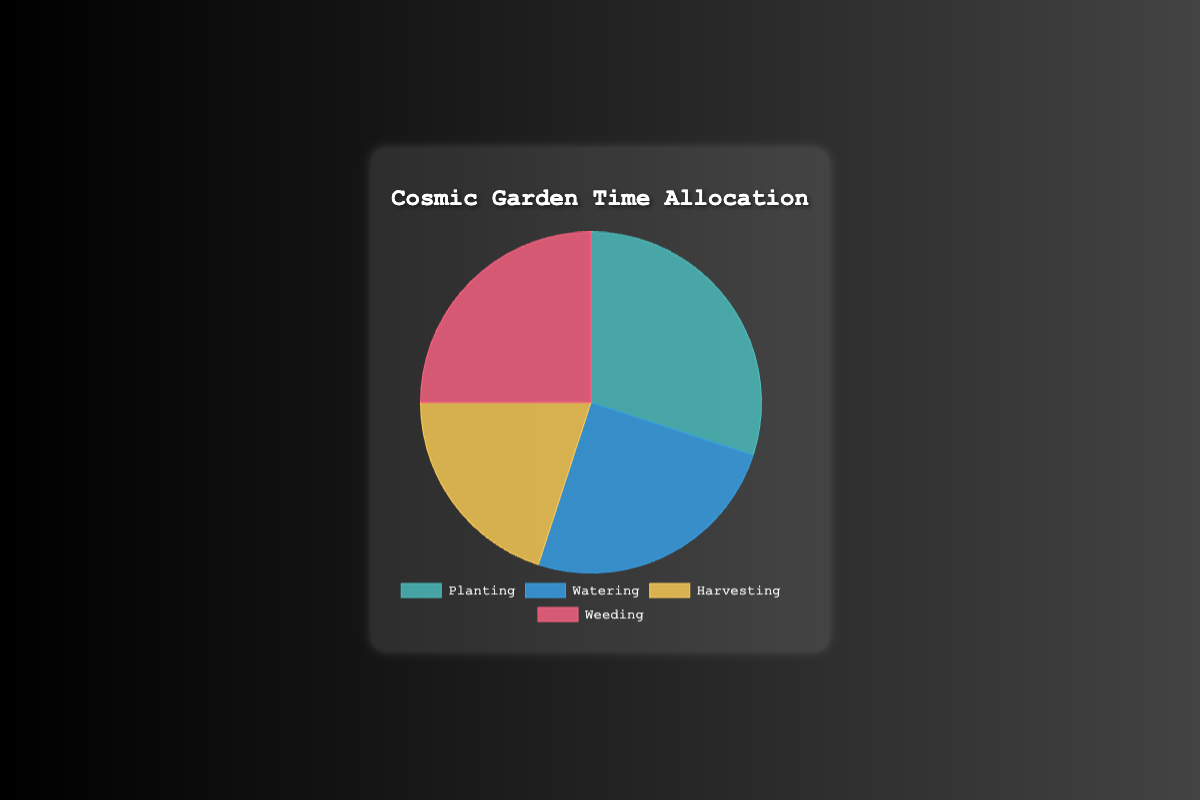Which gardening activity takes up the most time? The largest segment of the pie chart represents the activity with the highest percentage. In this chart, planting occupies 30% of the total time, which is the highest.
Answer: Planting Which two activities take up an equal amount of time? By observing the equal-sized segments of the pie chart, both watering and weeding each take up 25% of the total gardening time.
Answer: Watering and Weeding How much more time is spent on planting compared to harvesting? To find the difference, subtract the percentage time spent on harvesting from the time spent on planting. Planting takes up 30%, and harvesting takes up 20%. So, the difference is 30% - 20% = 10%.
Answer: 10% What is the total percentage of time spent on activities other than planting? To find this, subtract the percentage of time spent on planting from 100%. Planting takes up 30%, so the total percentage for other activities is 100% - 30% = 70%.
Answer: 70% Which activity takes up the least amount of time? The smallest segment of the pie chart represents harvesting, which occupies 20% of the total gardening time.
Answer: Harvesting What is the average percentage of time spent on each activity? To find the average, sum up all the percentages and divide by the number of activities. The total is 30% (planting) + 25% (watering) + 20% (harvesting) + 25% (weeding) = 100%. The average is 100% / 4 = 25%.
Answer: 25% Is the time spent on watering and weeding together greater than the time spent on planting? Add the percentages for watering and weeding, and compare to the percentage for planting. Watering (25%) + weeding (25%) = 50%, which is greater than planting (30%).
Answer: Yes Which color represents the activity with the second-highest time allocation? By reviewing the visual information, watering, and weeding tie for the second-highest time allocation of 25%. Watering is represented by blue, while weeding is represented by red. Either is a correct answer.
Answer: Blue or Red 